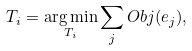<formula> <loc_0><loc_0><loc_500><loc_500>T _ { i } = \underset { T _ { i } } { \arg \min } \sum _ { j } O b j ( e _ { j } ) ,</formula> 